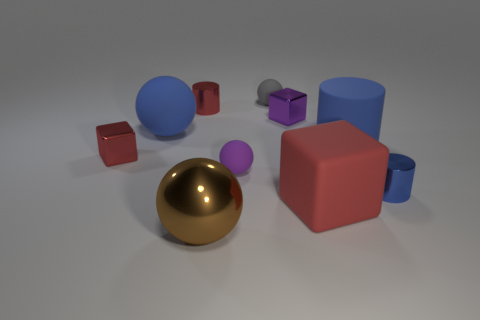Subtract 1 balls. How many balls are left? 3 Subtract all cylinders. How many objects are left? 7 Add 10 red matte balls. How many red matte balls exist? 10 Subtract 1 purple blocks. How many objects are left? 9 Subtract all tiny purple balls. Subtract all big blue matte cylinders. How many objects are left? 8 Add 8 tiny red cylinders. How many tiny red cylinders are left? 9 